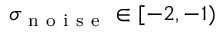Convert formula to latex. <formula><loc_0><loc_0><loc_500><loc_500>\sigma _ { n o i s e } \in [ - 2 , - 1 )</formula> 